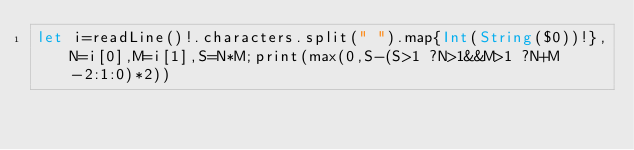Convert code to text. <code><loc_0><loc_0><loc_500><loc_500><_Swift_>let i=readLine()!.characters.split(" ").map{Int(String($0))!},N=i[0],M=i[1],S=N*M;print(max(0,S-(S>1 ?N>1&&M>1 ?N+M-2:1:0)*2))</code> 